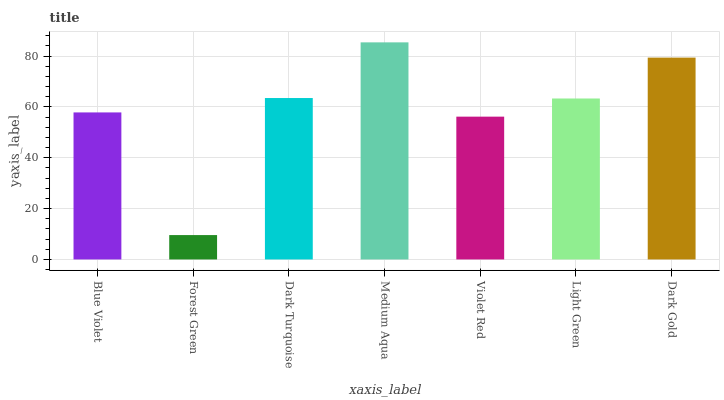Is Forest Green the minimum?
Answer yes or no. Yes. Is Medium Aqua the maximum?
Answer yes or no. Yes. Is Dark Turquoise the minimum?
Answer yes or no. No. Is Dark Turquoise the maximum?
Answer yes or no. No. Is Dark Turquoise greater than Forest Green?
Answer yes or no. Yes. Is Forest Green less than Dark Turquoise?
Answer yes or no. Yes. Is Forest Green greater than Dark Turquoise?
Answer yes or no. No. Is Dark Turquoise less than Forest Green?
Answer yes or no. No. Is Light Green the high median?
Answer yes or no. Yes. Is Light Green the low median?
Answer yes or no. Yes. Is Forest Green the high median?
Answer yes or no. No. Is Forest Green the low median?
Answer yes or no. No. 